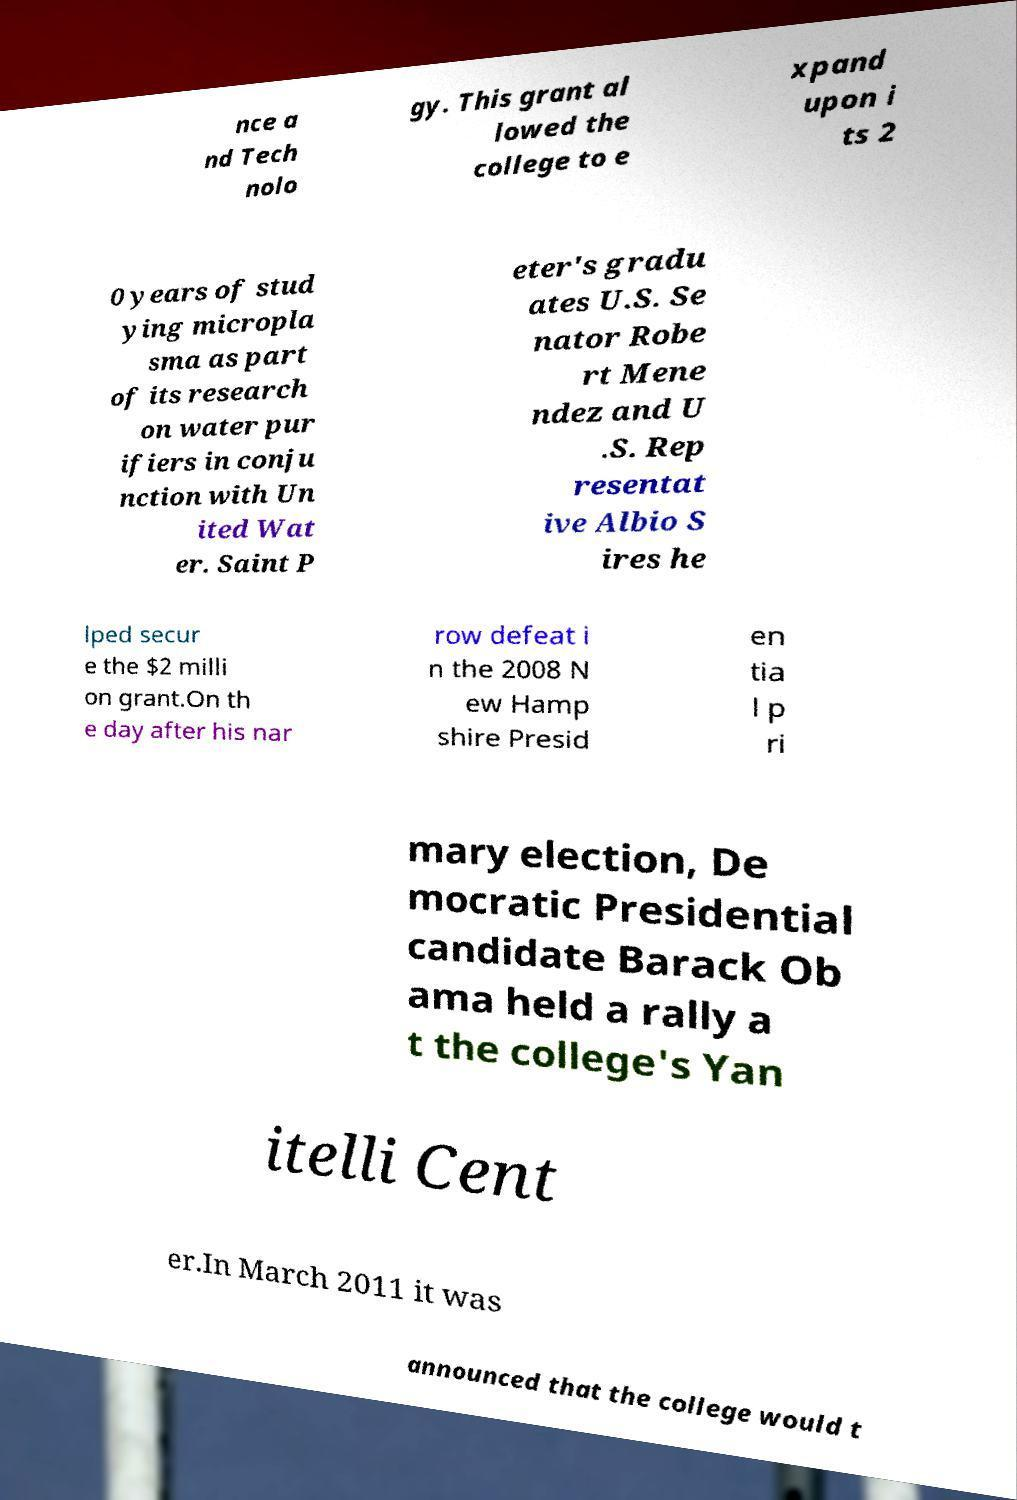Can you accurately transcribe the text from the provided image for me? nce a nd Tech nolo gy. This grant al lowed the college to e xpand upon i ts 2 0 years of stud ying micropla sma as part of its research on water pur ifiers in conju nction with Un ited Wat er. Saint P eter's gradu ates U.S. Se nator Robe rt Mene ndez and U .S. Rep resentat ive Albio S ires he lped secur e the $2 milli on grant.On th e day after his nar row defeat i n the 2008 N ew Hamp shire Presid en tia l p ri mary election, De mocratic Presidential candidate Barack Ob ama held a rally a t the college's Yan itelli Cent er.In March 2011 it was announced that the college would t 